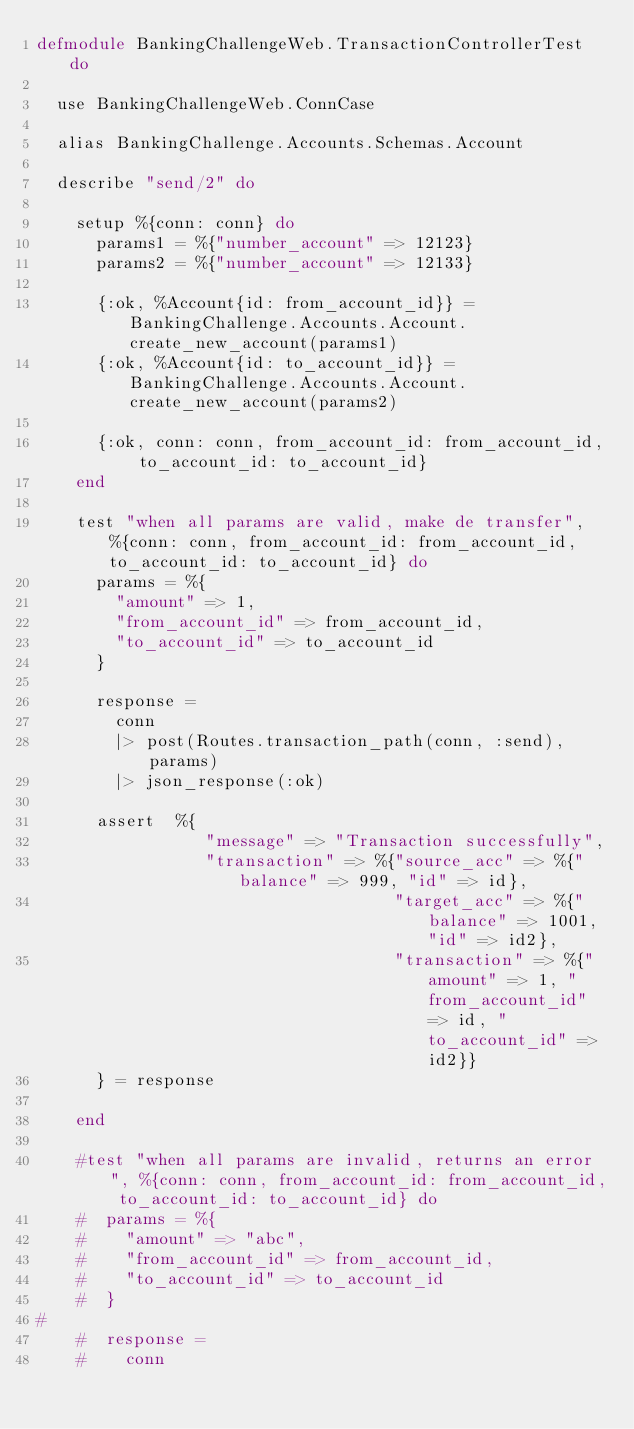Convert code to text. <code><loc_0><loc_0><loc_500><loc_500><_Elixir_>defmodule BankingChallengeWeb.TransactionControllerTest do

  use BankingChallengeWeb.ConnCase

  alias BankingChallenge.Accounts.Schemas.Account

  describe "send/2" do

    setup %{conn: conn} do
      params1 = %{"number_account" => 12123}
      params2 = %{"number_account" => 12133}

      {:ok, %Account{id: from_account_id}} = BankingChallenge.Accounts.Account.create_new_account(params1)
      {:ok, %Account{id: to_account_id}} = BankingChallenge.Accounts.Account.create_new_account(params2)

      {:ok, conn: conn, from_account_id: from_account_id, to_account_id: to_account_id}
    end

    test "when all params are valid, make de transfer", %{conn: conn, from_account_id: from_account_id, to_account_id: to_account_id} do
      params = %{
        "amount" => 1,
        "from_account_id" => from_account_id,
        "to_account_id" => to_account_id
      }

      response =
        conn
        |> post(Routes.transaction_path(conn, :send), params)
        |> json_response(:ok)

      assert  %{
                 "message" => "Transaction successfully",
                 "transaction" => %{"source_acc" => %{"balance" => 999, "id" => id},
                                    "target_acc" => %{"balance" => 1001, "id" => id2},
                                    "transaction" => %{"amount" => 1, "from_account_id" => id, "to_account_id" => id2}}
      } = response

    end

    #test "when all params are invalid, returns an error", %{conn: conn, from_account_id: from_account_id, to_account_id: to_account_id} do
    #  params = %{
    #    "amount" => "abc",
    #    "from_account_id" => from_account_id,
    #    "to_account_id" => to_account_id
    #  }
#
    #  response =
    #    conn</code> 